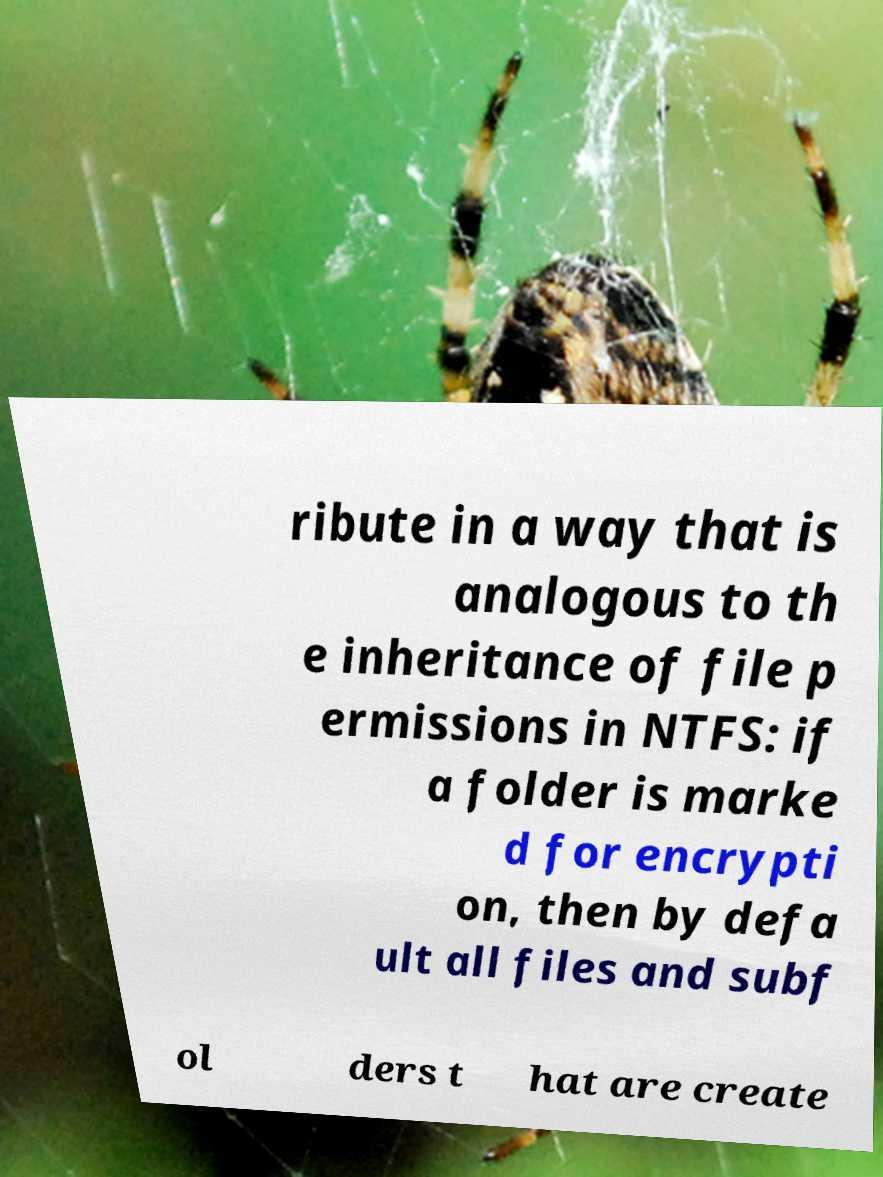I need the written content from this picture converted into text. Can you do that? ribute in a way that is analogous to th e inheritance of file p ermissions in NTFS: if a folder is marke d for encrypti on, then by defa ult all files and subf ol ders t hat are create 